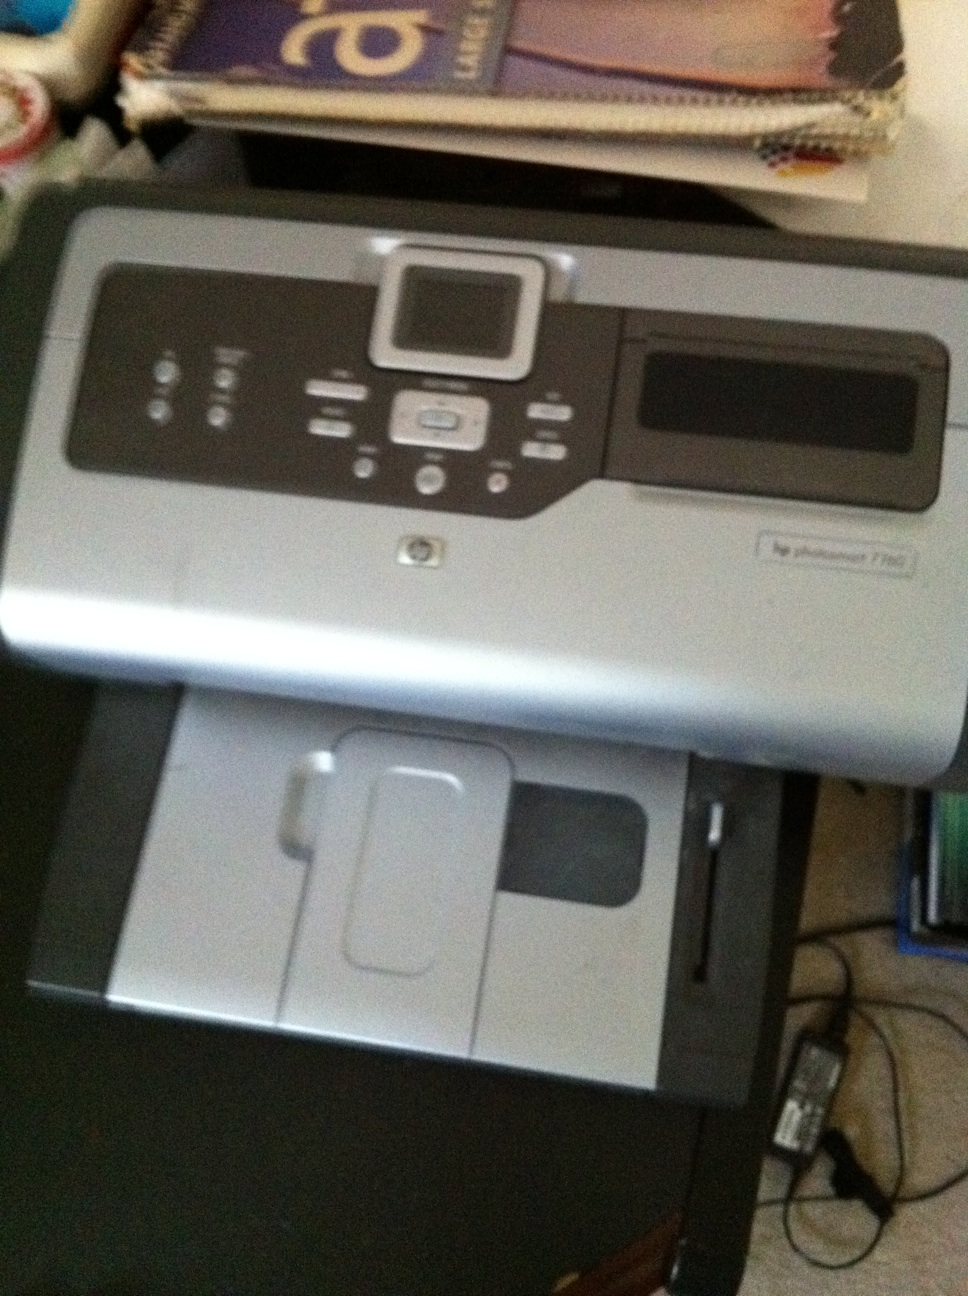Could you write a short story detailing a day in the life of this printer in a busy office? In the bustling office of Creative Designs, the HP Photosmart 7280 hums to life as the first rays of dawn peek through the windows. The designers rush in, already brainstorming, their ideas pouring onto sketchpads and computer screens. The printer springs into action, churning out vibrant photos for the latest campaign. Throughout the day, it tirelessly scans contracts, copies important documents, and prints creativity incarnate. Each print job tells a small part of a larger story, of designs brought to life and dreams given form. As the office winds down, the printer hums a quiet song of accomplishment, resting until the next morning brings new ideas to ink. 